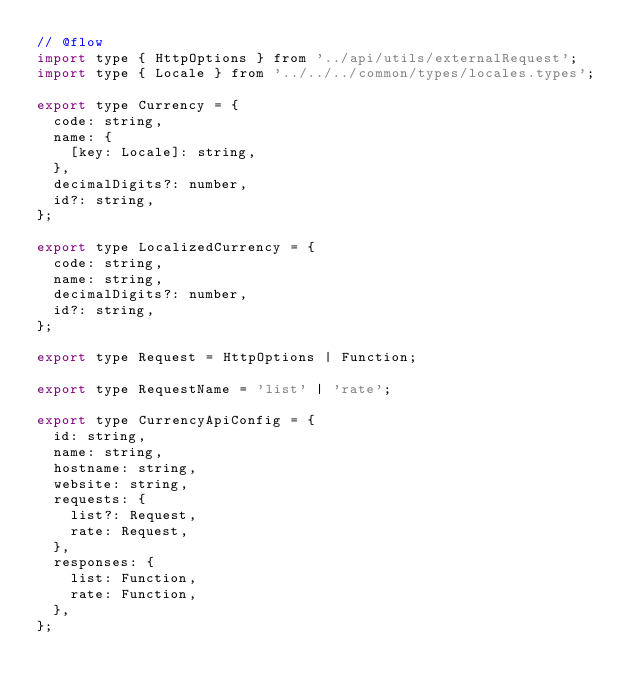Convert code to text. <code><loc_0><loc_0><loc_500><loc_500><_JavaScript_>// @flow
import type { HttpOptions } from '../api/utils/externalRequest';
import type { Locale } from '../../../common/types/locales.types';

export type Currency = {
  code: string,
  name: {
    [key: Locale]: string,
  },
  decimalDigits?: number,
  id?: string,
};

export type LocalizedCurrency = {
  code: string,
  name: string,
  decimalDigits?: number,
  id?: string,
};

export type Request = HttpOptions | Function;

export type RequestName = 'list' | 'rate';

export type CurrencyApiConfig = {
  id: string,
  name: string,
  hostname: string,
  website: string,
  requests: {
    list?: Request,
    rate: Request,
  },
  responses: {
    list: Function,
    rate: Function,
  },
};
</code> 